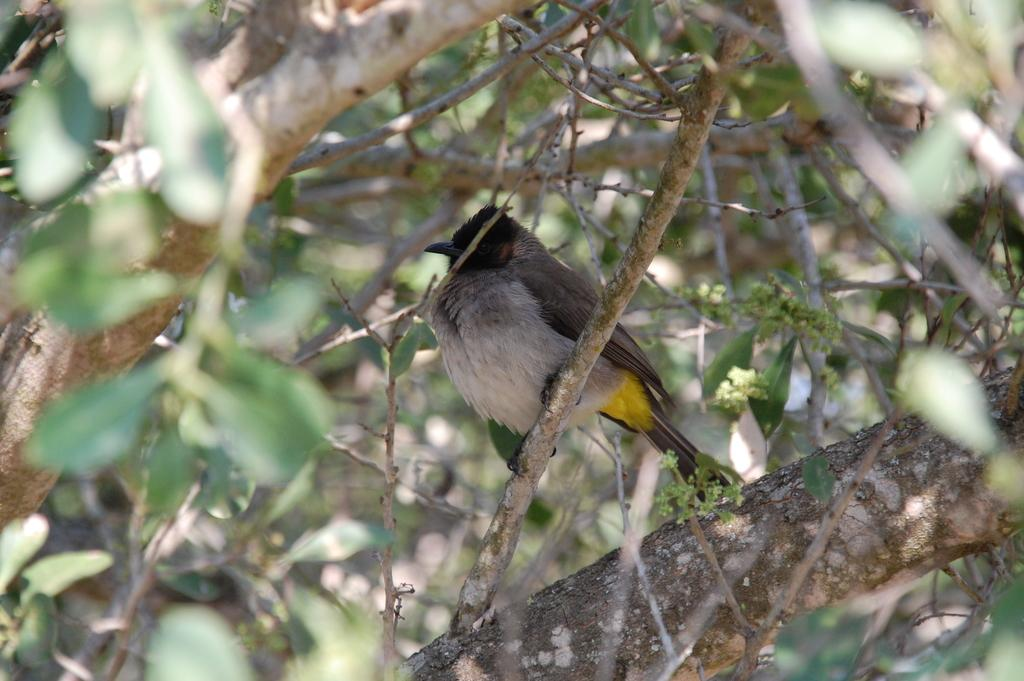What type of animal can be seen in the image? There is a bird in the image. Where is the bird located in the image? The bird is sitting on a branch. What is the branch a part of? The branch is part of a tree. What can be observed on the tree? There are leaves on the tree. What type of error can be seen in the image? There is no error present in the image; it features a bird sitting on a branch of a tree with leaves. Can you tell me how many dinosaurs are visible in the image? There are no dinosaurs present in the image; it features a bird sitting on a branch of a tree with leaves. 